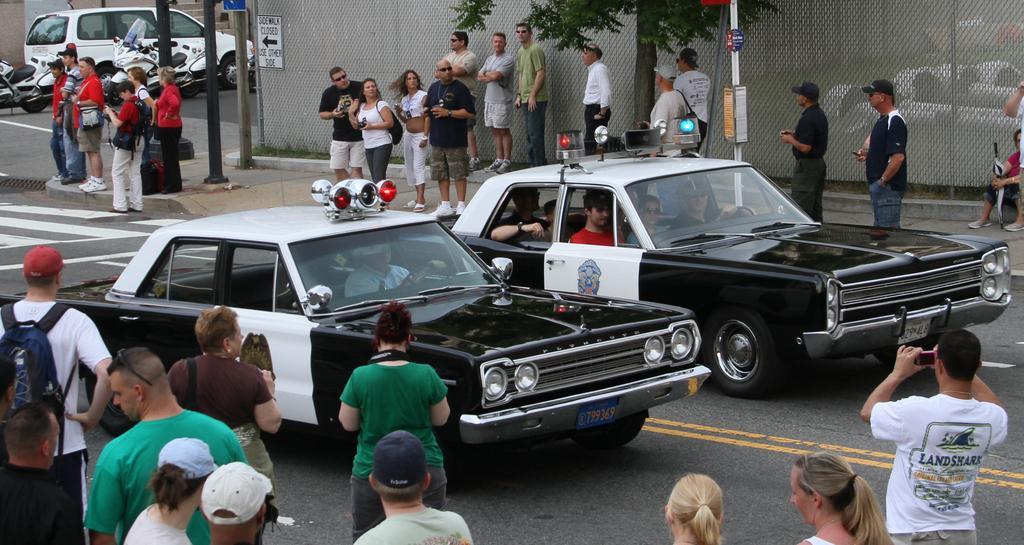In one or two sentences, can you explain what this image depicts? In the picture there are two cars moving on the road and around those cars, many people were standing and some of them are capturing the photos of those cars. On the left side there are few vehicles parked beside the road. 